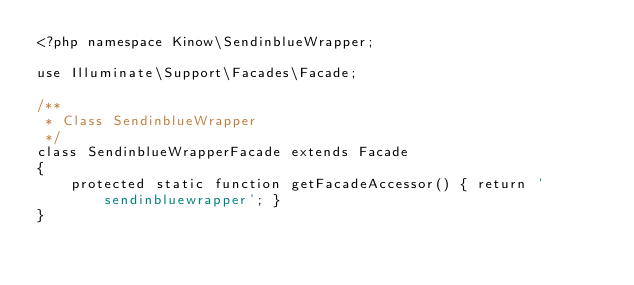Convert code to text. <code><loc_0><loc_0><loc_500><loc_500><_PHP_><?php namespace Kinow\SendinblueWrapper;

use Illuminate\Support\Facades\Facade;

/**
 * Class SendinblueWrapper
 */
class SendinblueWrapperFacade extends Facade
{
    protected static function getFacadeAccessor() { return 'sendinbluewrapper'; }
}</code> 